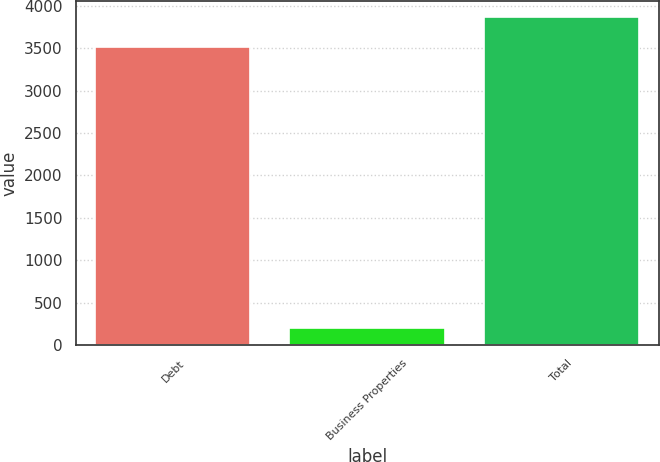Convert chart to OTSL. <chart><loc_0><loc_0><loc_500><loc_500><bar_chart><fcel>Debt<fcel>Business Properties<fcel>Total<nl><fcel>3515<fcel>197<fcel>3866.5<nl></chart> 